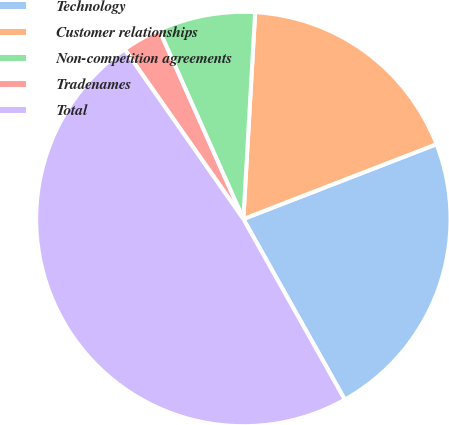Convert chart to OTSL. <chart><loc_0><loc_0><loc_500><loc_500><pie_chart><fcel>Technology<fcel>Customer relationships<fcel>Non-competition agreements<fcel>Tradenames<fcel>Total<nl><fcel>22.74%<fcel>18.21%<fcel>7.58%<fcel>3.04%<fcel>48.43%<nl></chart> 